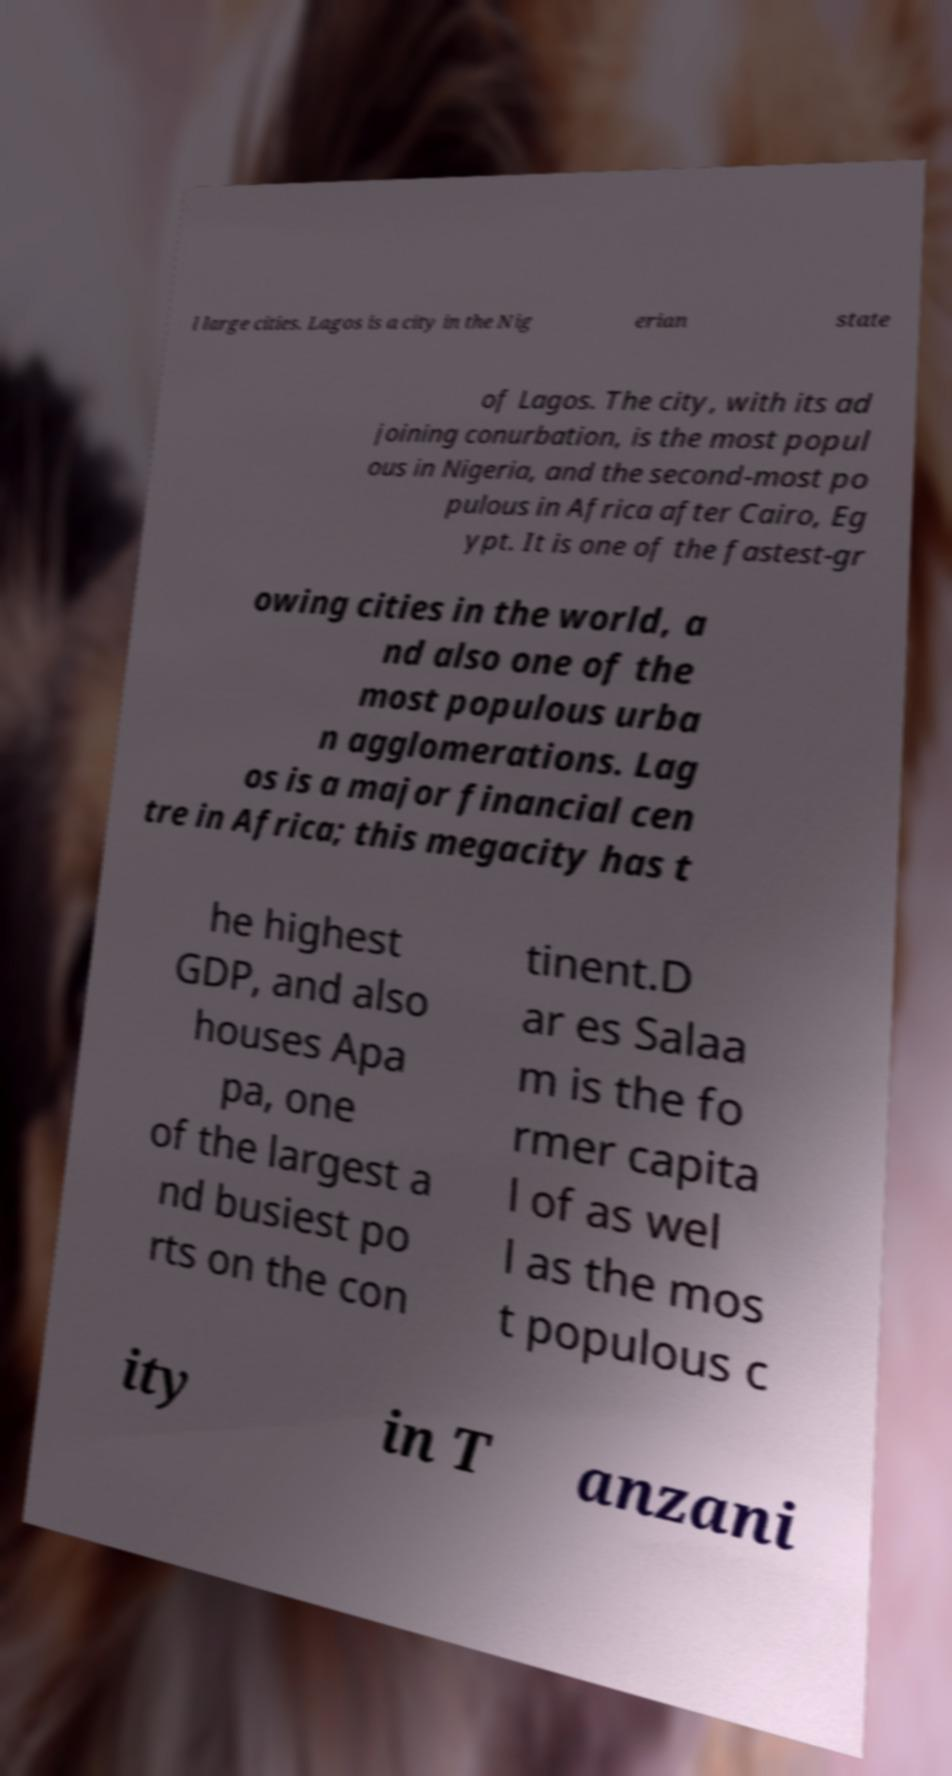Can you accurately transcribe the text from the provided image for me? l large cities. Lagos is a city in the Nig erian state of Lagos. The city, with its ad joining conurbation, is the most popul ous in Nigeria, and the second-most po pulous in Africa after Cairo, Eg ypt. It is one of the fastest-gr owing cities in the world, a nd also one of the most populous urba n agglomerations. Lag os is a major financial cen tre in Africa; this megacity has t he highest GDP, and also houses Apa pa, one of the largest a nd busiest po rts on the con tinent.D ar es Salaa m is the fo rmer capita l of as wel l as the mos t populous c ity in T anzani 